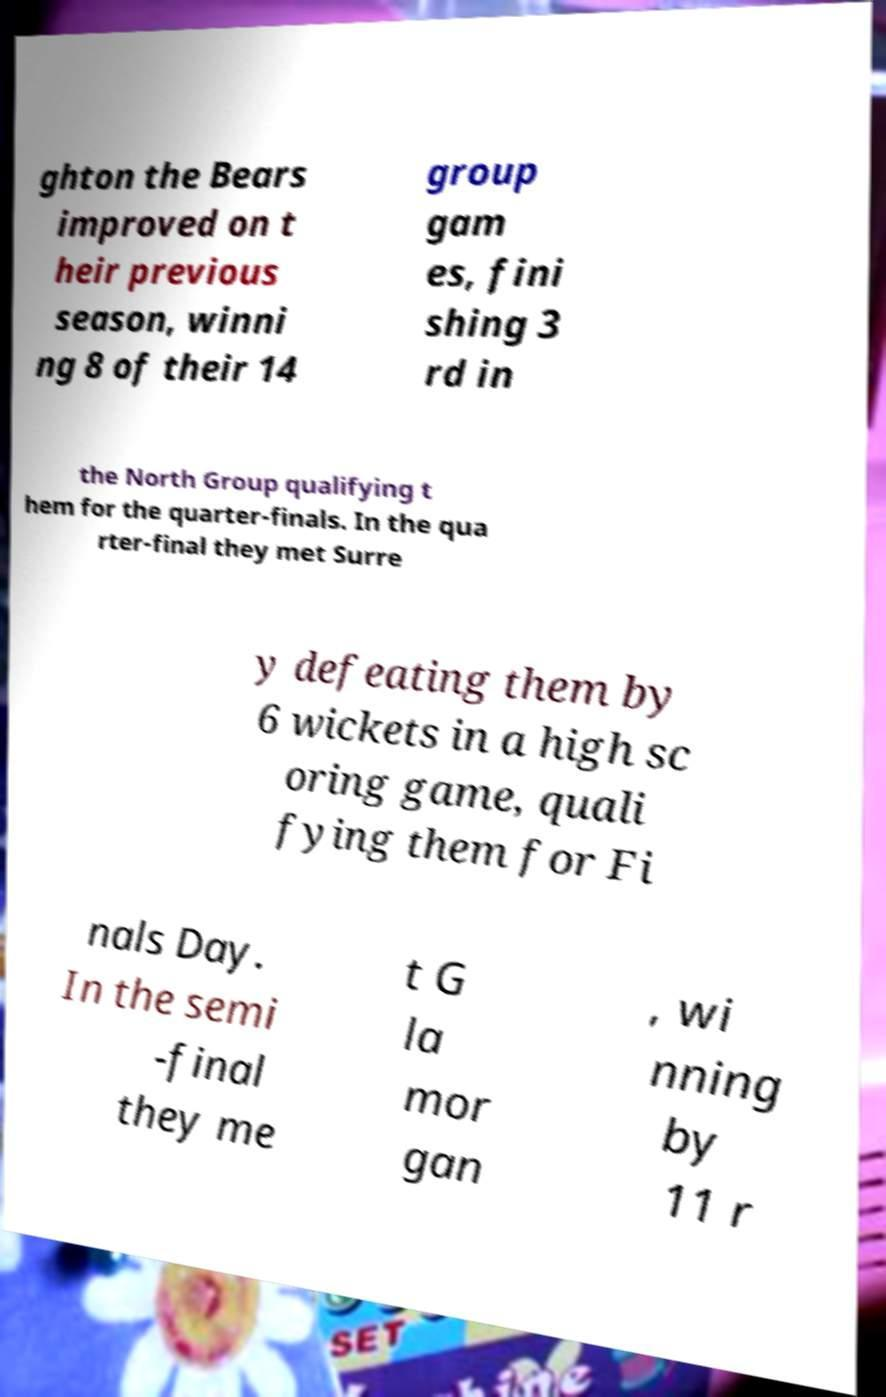I need the written content from this picture converted into text. Can you do that? ghton the Bears improved on t heir previous season, winni ng 8 of their 14 group gam es, fini shing 3 rd in the North Group qualifying t hem for the quarter-finals. In the qua rter-final they met Surre y defeating them by 6 wickets in a high sc oring game, quali fying them for Fi nals Day. In the semi -final they me t G la mor gan , wi nning by 11 r 